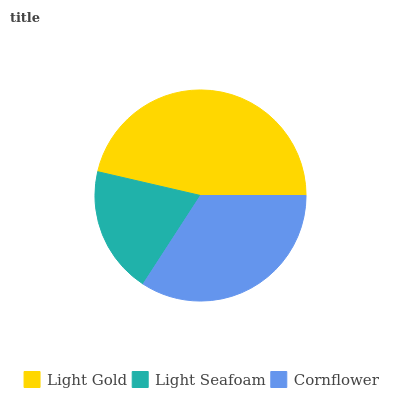Is Light Seafoam the minimum?
Answer yes or no. Yes. Is Light Gold the maximum?
Answer yes or no. Yes. Is Cornflower the minimum?
Answer yes or no. No. Is Cornflower the maximum?
Answer yes or no. No. Is Cornflower greater than Light Seafoam?
Answer yes or no. Yes. Is Light Seafoam less than Cornflower?
Answer yes or no. Yes. Is Light Seafoam greater than Cornflower?
Answer yes or no. No. Is Cornflower less than Light Seafoam?
Answer yes or no. No. Is Cornflower the high median?
Answer yes or no. Yes. Is Cornflower the low median?
Answer yes or no. Yes. Is Light Gold the high median?
Answer yes or no. No. Is Light Seafoam the low median?
Answer yes or no. No. 